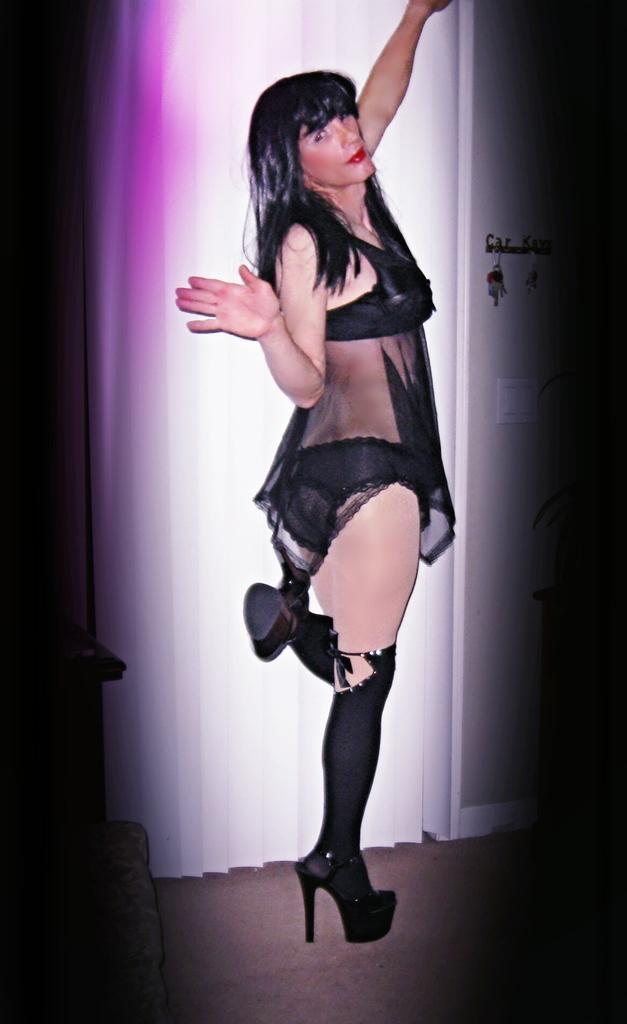Please provide a concise description of this image. In this image we can see a woman standing on the floor. In the background we can see curtain, door and a key holder attached to the door. 